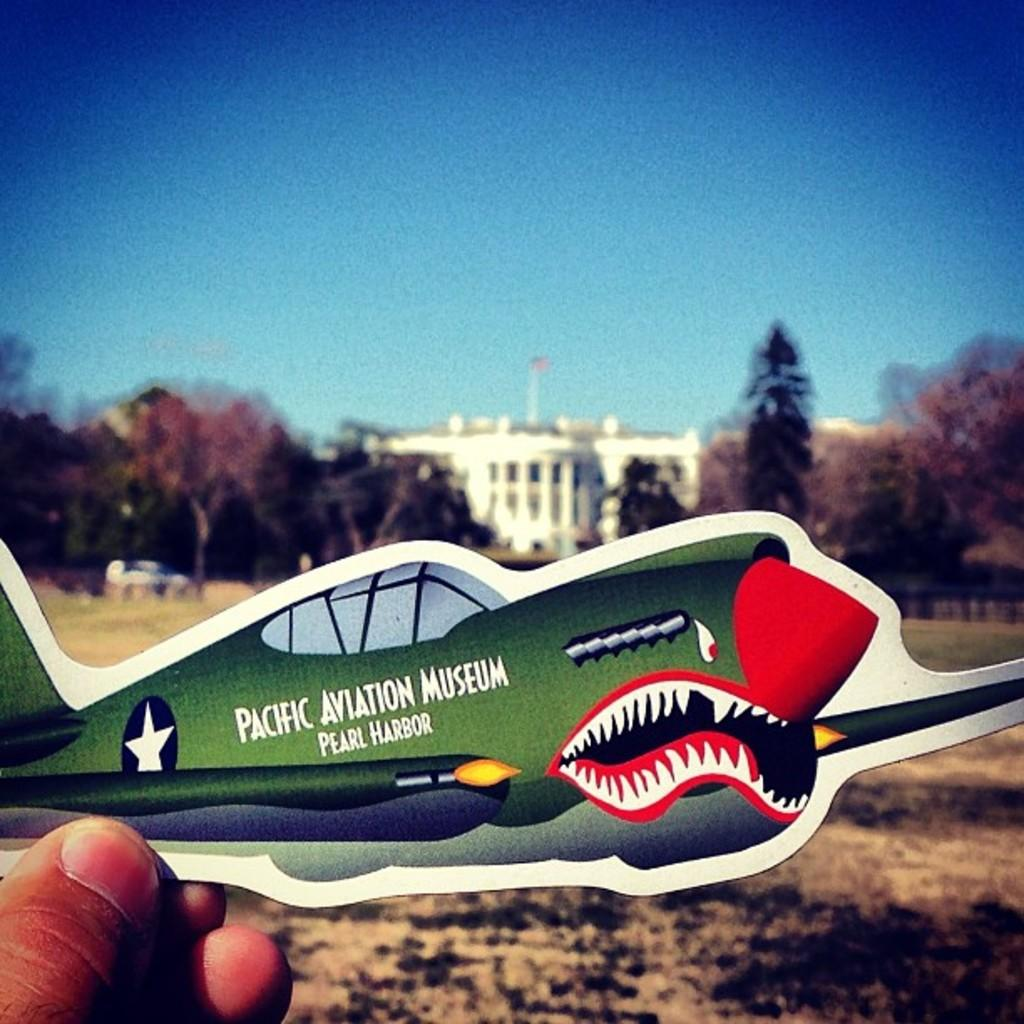What type of natural elements can be seen in the image? There are trees in the image. What type of man-made structure is present in the image? There is a building in the image. What is the person holding in the image? A human hand is holding a sticker of a plane. How would you describe the weather conditions based on the image? The sky is cloudy in the image. What type of vehicle can be seen in the image? There appears to be a car parked in the image. Are there any cornfields visible in the image? There is no cornfield present in the image. How many chickens are roaming around the car in the image? There are no chickens visible in the image. 